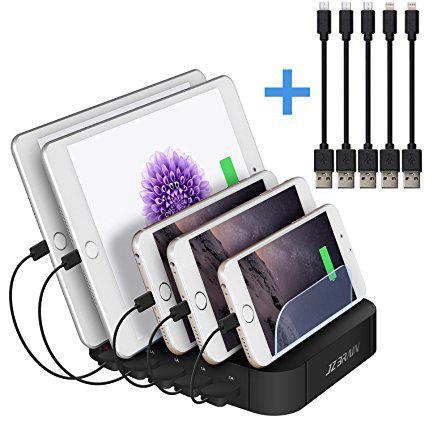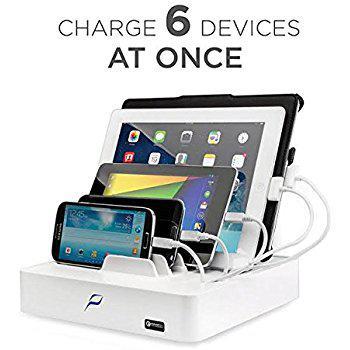The first image is the image on the left, the second image is the image on the right. Evaluate the accuracy of this statement regarding the images: "The devices in the left image are plugged into a black colored charging station.". Is it true? Answer yes or no. Yes. The first image is the image on the left, the second image is the image on the right. Analyze the images presented: Is the assertion "An image shows an upright charging station with one white cord in the back and several cords all of one color in the front, with multiple screened devices lying flat nearby it on a wood-grain surface." valid? Answer yes or no. No. 